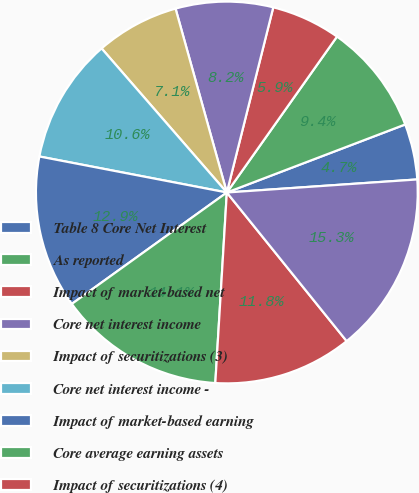Convert chart to OTSL. <chart><loc_0><loc_0><loc_500><loc_500><pie_chart><fcel>Table 8 Core Net Interest<fcel>As reported<fcel>Impact of market-based net<fcel>Core net interest income<fcel>Impact of securitizations (3)<fcel>Core net interest income -<fcel>Impact of market-based earning<fcel>Core average earning assets<fcel>Impact of securitizations (4)<fcel>Core average earning assets -<nl><fcel>4.71%<fcel>9.41%<fcel>5.88%<fcel>8.24%<fcel>7.06%<fcel>10.59%<fcel>12.94%<fcel>14.12%<fcel>11.76%<fcel>15.29%<nl></chart> 